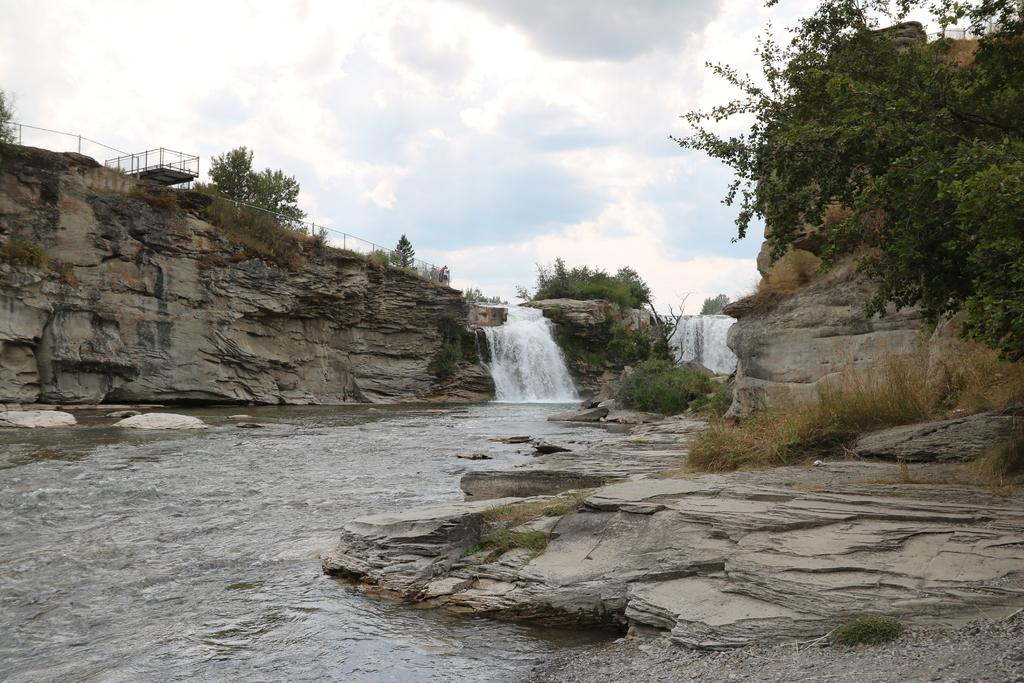What natural feature is the main subject of the image? There is a waterfall in the image. Where is the water coming from in the image? The water is flowing from a hill in the image. What is located on the left side above the hill? There is a fencing on the left side above the hill. What type of vegetation can be seen behind the fencing? There are many trees behind the fencing in the image. What type of experience does the mother have with the sofa in the image? There is no mention of a mother or a sofa in the image; it features a waterfall, a hill, a fencing, and trees. 